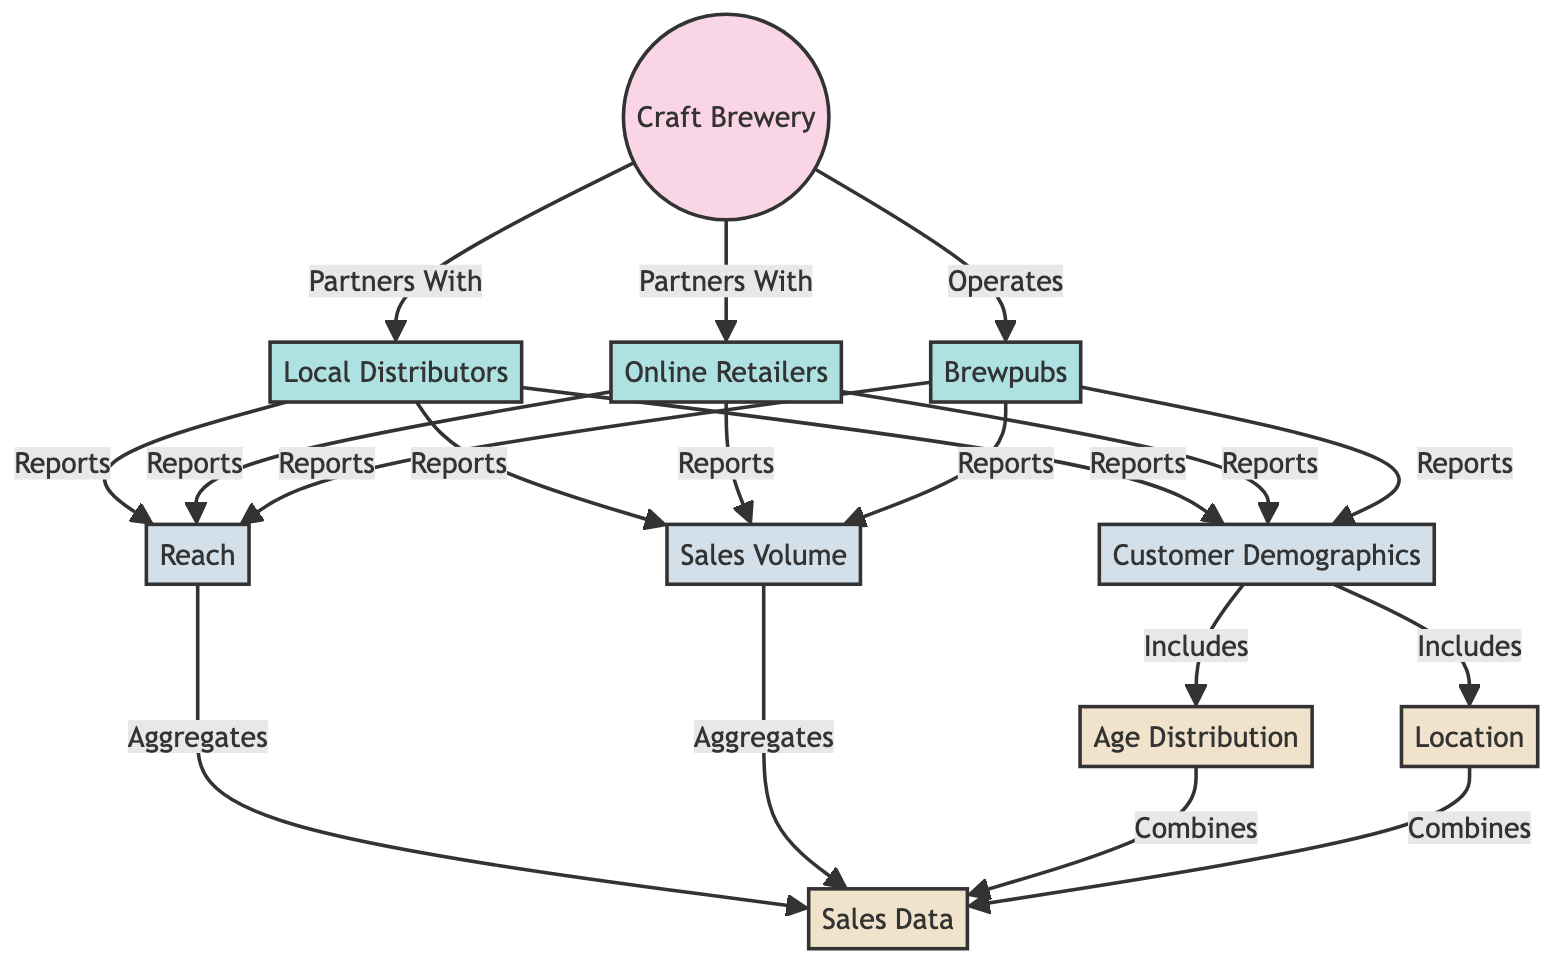What types of distributors does the craft brewery partner with? The diagram shows that the craft brewery partners with three types of distributors: local distributors, online retailers, and brewpubs. This information is derived directly from the connections illustrated in the diagram.
Answer: Local Distributors, Online Retailers, Brewpubs How many metrics are reported by the distributors? The distributors report on three different metrics: reach, sales volume, and customer demographics. This is indicated by the connections from the distributors to these metrics in the diagram.
Answer: Three What does the age distribution connect to in the diagram? The age distribution node is connected to the sales data node, indicating that age distribution is a component or category included within the broader sales data analysis.
Answer: Sales Data Which entity operates the brewpubs? According to the diagram, the craft brewery is the entity that operates the brewpubs, as indicated by the direct relationship from the brewery to the brewpub node.
Answer: Craft Brewery What do customer demographics include? The customer demographics metric includes two components: age distribution and location. This is depicted by the directed arrows from the customer demographics to the age distribution and location nodes.
Answer: Age Distribution, Location How does reach aggregate data in the diagram? The reach metric aggregates data by directly connecting to the sales data node. This indicates that reach incorporates or sums up sales data for analysis.
Answer: Sales Data What information do online retailers report? Online retailers report on the same three metrics as local distributors and brewpubs: reach, sales volume, and customer demographics. These are shown as direct reports from the online retailers node to the respective metrics nodes.
Answer: Reach, Sales Volume, Customer Demographics What is the primary function of the craft brewery in this diagram? The primary function of the craft brewery is to partner with distributors and operate brewpubs, as indicated by the arrows leading from the brewery node to others in the diagram.
Answer: Partners and Operates 